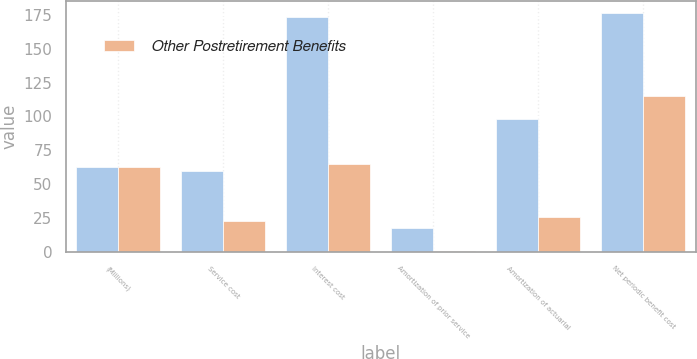<chart> <loc_0><loc_0><loc_500><loc_500><stacked_bar_chart><ecel><fcel>(Millions)<fcel>Service cost<fcel>Interest cost<fcel>Amortization of prior service<fcel>Amortization of actuarial<fcel>Net periodic benefit cost<nl><fcel>nan<fcel>62.5<fcel>60<fcel>173<fcel>18<fcel>98<fcel>176<nl><fcel>Other Postretirement Benefits<fcel>62.5<fcel>23<fcel>65<fcel>1<fcel>26<fcel>115<nl></chart> 